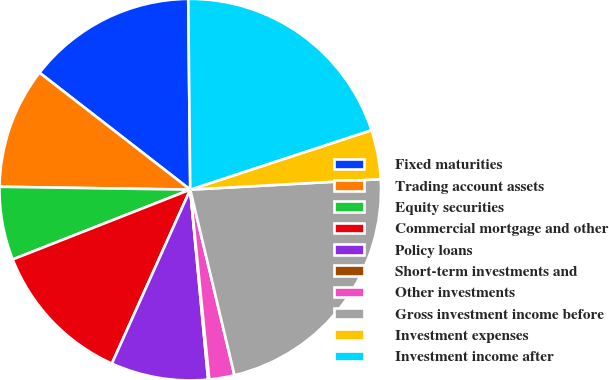<chart> <loc_0><loc_0><loc_500><loc_500><pie_chart><fcel>Fixed maturities<fcel>Trading account assets<fcel>Equity securities<fcel>Commercial mortgage and other<fcel>Policy loans<fcel>Short-term investments and<fcel>Other investments<fcel>Gross investment income before<fcel>Investment expenses<fcel>Investment income after<nl><fcel>14.33%<fcel>10.26%<fcel>6.2%<fcel>12.3%<fcel>8.23%<fcel>0.1%<fcel>2.13%<fcel>22.15%<fcel>4.17%<fcel>20.12%<nl></chart> 